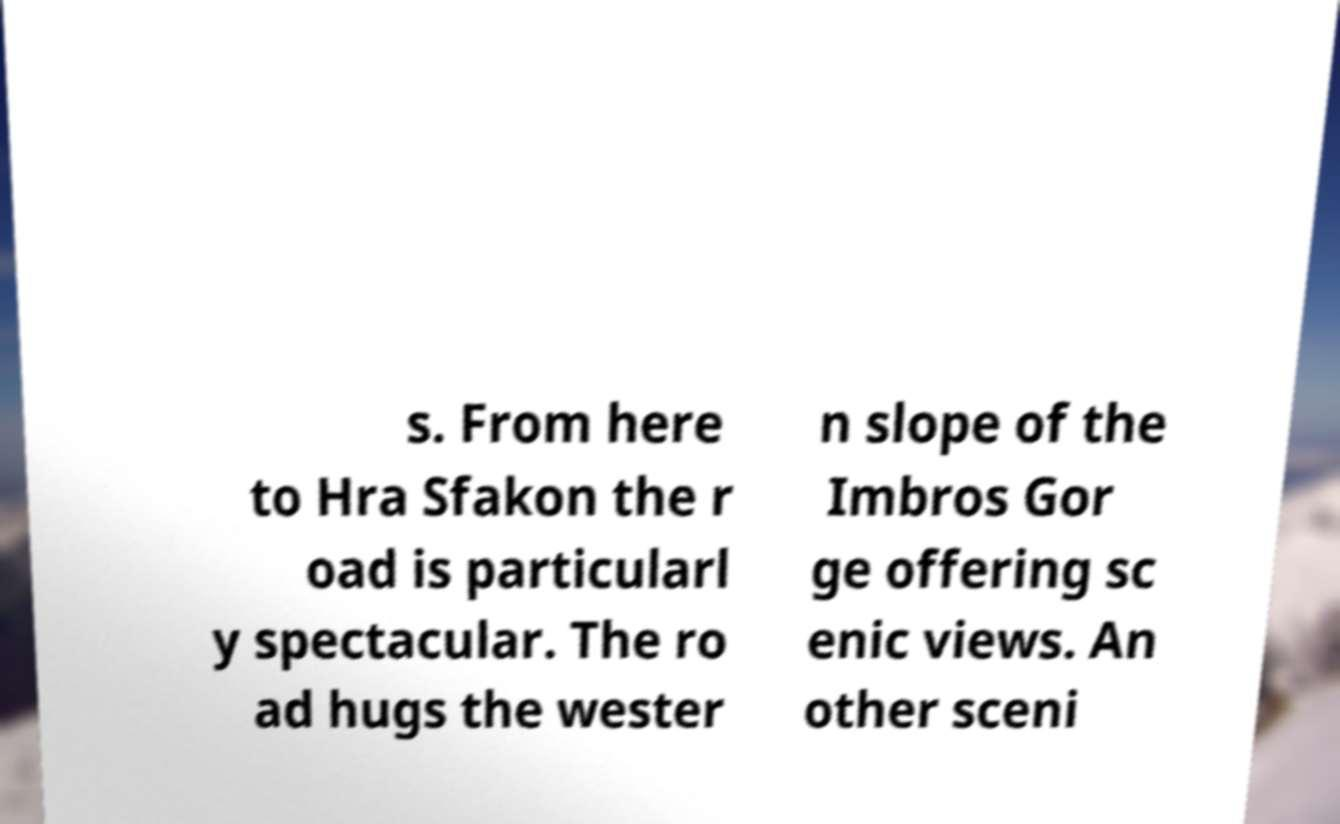Could you assist in decoding the text presented in this image and type it out clearly? s. From here to Hra Sfakon the r oad is particularl y spectacular. The ro ad hugs the wester n slope of the Imbros Gor ge offering sc enic views. An other sceni 